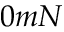<formula> <loc_0><loc_0><loc_500><loc_500>0 m N</formula> 